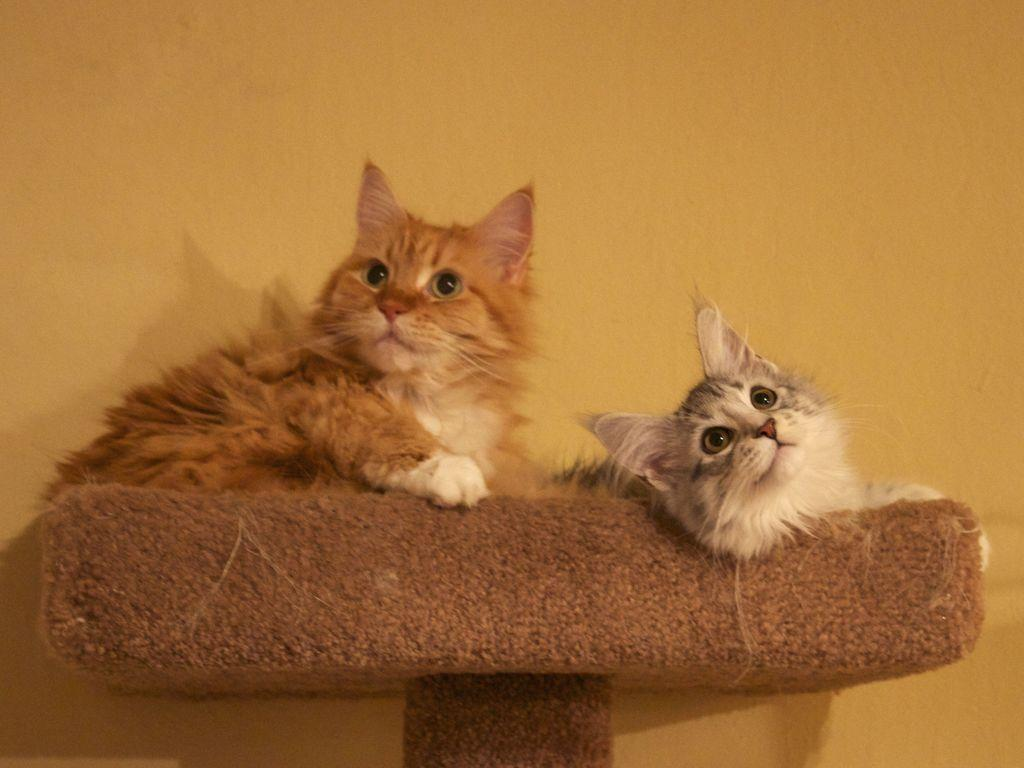How many cats are present in the image? There are two cats in the image. What are the cats doing or positioned on in the image? The cats are on an object in the image. What can be seen in the background of the image? There is a yellow color wall in the background of the image. What is the weight of the cats in the image? The weight of the cats cannot be determined from the image alone. --- 